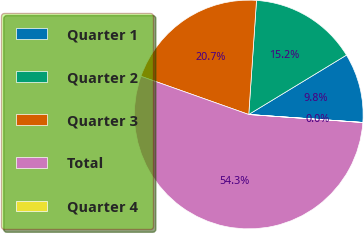Convert chart. <chart><loc_0><loc_0><loc_500><loc_500><pie_chart><fcel>Quarter 1<fcel>Quarter 2<fcel>Quarter 3<fcel>Total<fcel>Quarter 4<nl><fcel>9.8%<fcel>15.23%<fcel>20.66%<fcel>54.31%<fcel>0.01%<nl></chart> 